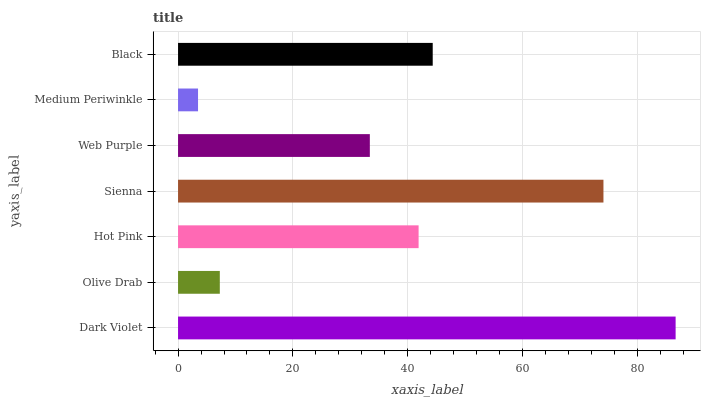Is Medium Periwinkle the minimum?
Answer yes or no. Yes. Is Dark Violet the maximum?
Answer yes or no. Yes. Is Olive Drab the minimum?
Answer yes or no. No. Is Olive Drab the maximum?
Answer yes or no. No. Is Dark Violet greater than Olive Drab?
Answer yes or no. Yes. Is Olive Drab less than Dark Violet?
Answer yes or no. Yes. Is Olive Drab greater than Dark Violet?
Answer yes or no. No. Is Dark Violet less than Olive Drab?
Answer yes or no. No. Is Hot Pink the high median?
Answer yes or no. Yes. Is Hot Pink the low median?
Answer yes or no. Yes. Is Dark Violet the high median?
Answer yes or no. No. Is Dark Violet the low median?
Answer yes or no. No. 